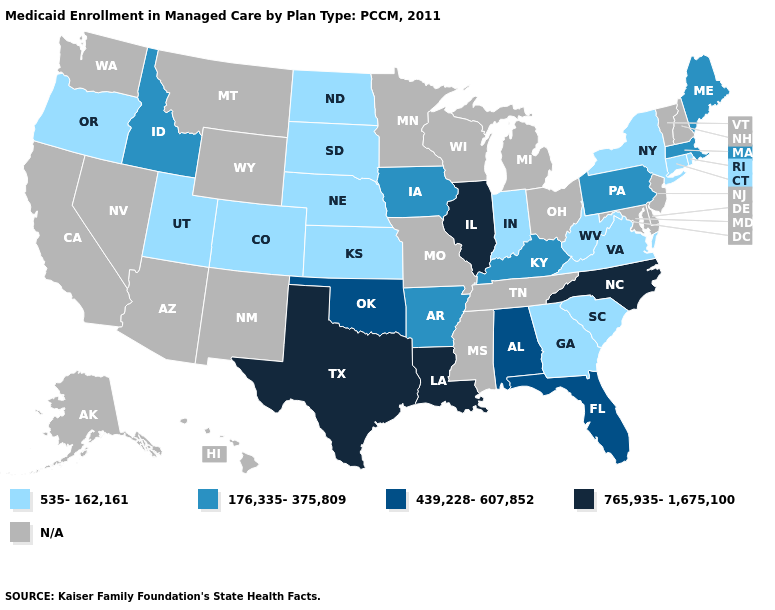How many symbols are there in the legend?
Keep it brief. 5. Name the states that have a value in the range 535-162,161?
Quick response, please. Colorado, Connecticut, Georgia, Indiana, Kansas, Nebraska, New York, North Dakota, Oregon, Rhode Island, South Carolina, South Dakota, Utah, Virginia, West Virginia. How many symbols are there in the legend?
Short answer required. 5. Which states hav the highest value in the West?
Be succinct. Idaho. What is the lowest value in states that border Wisconsin?
Short answer required. 176,335-375,809. Name the states that have a value in the range 765,935-1,675,100?
Answer briefly. Illinois, Louisiana, North Carolina, Texas. What is the value of Maryland?
Concise answer only. N/A. What is the highest value in the USA?
Concise answer only. 765,935-1,675,100. What is the highest value in the Northeast ?
Short answer required. 176,335-375,809. How many symbols are there in the legend?
Short answer required. 5. Does the map have missing data?
Give a very brief answer. Yes. What is the value of Connecticut?
Short answer required. 535-162,161. What is the value of New Jersey?
Be succinct. N/A. What is the value of Georgia?
Keep it brief. 535-162,161. 